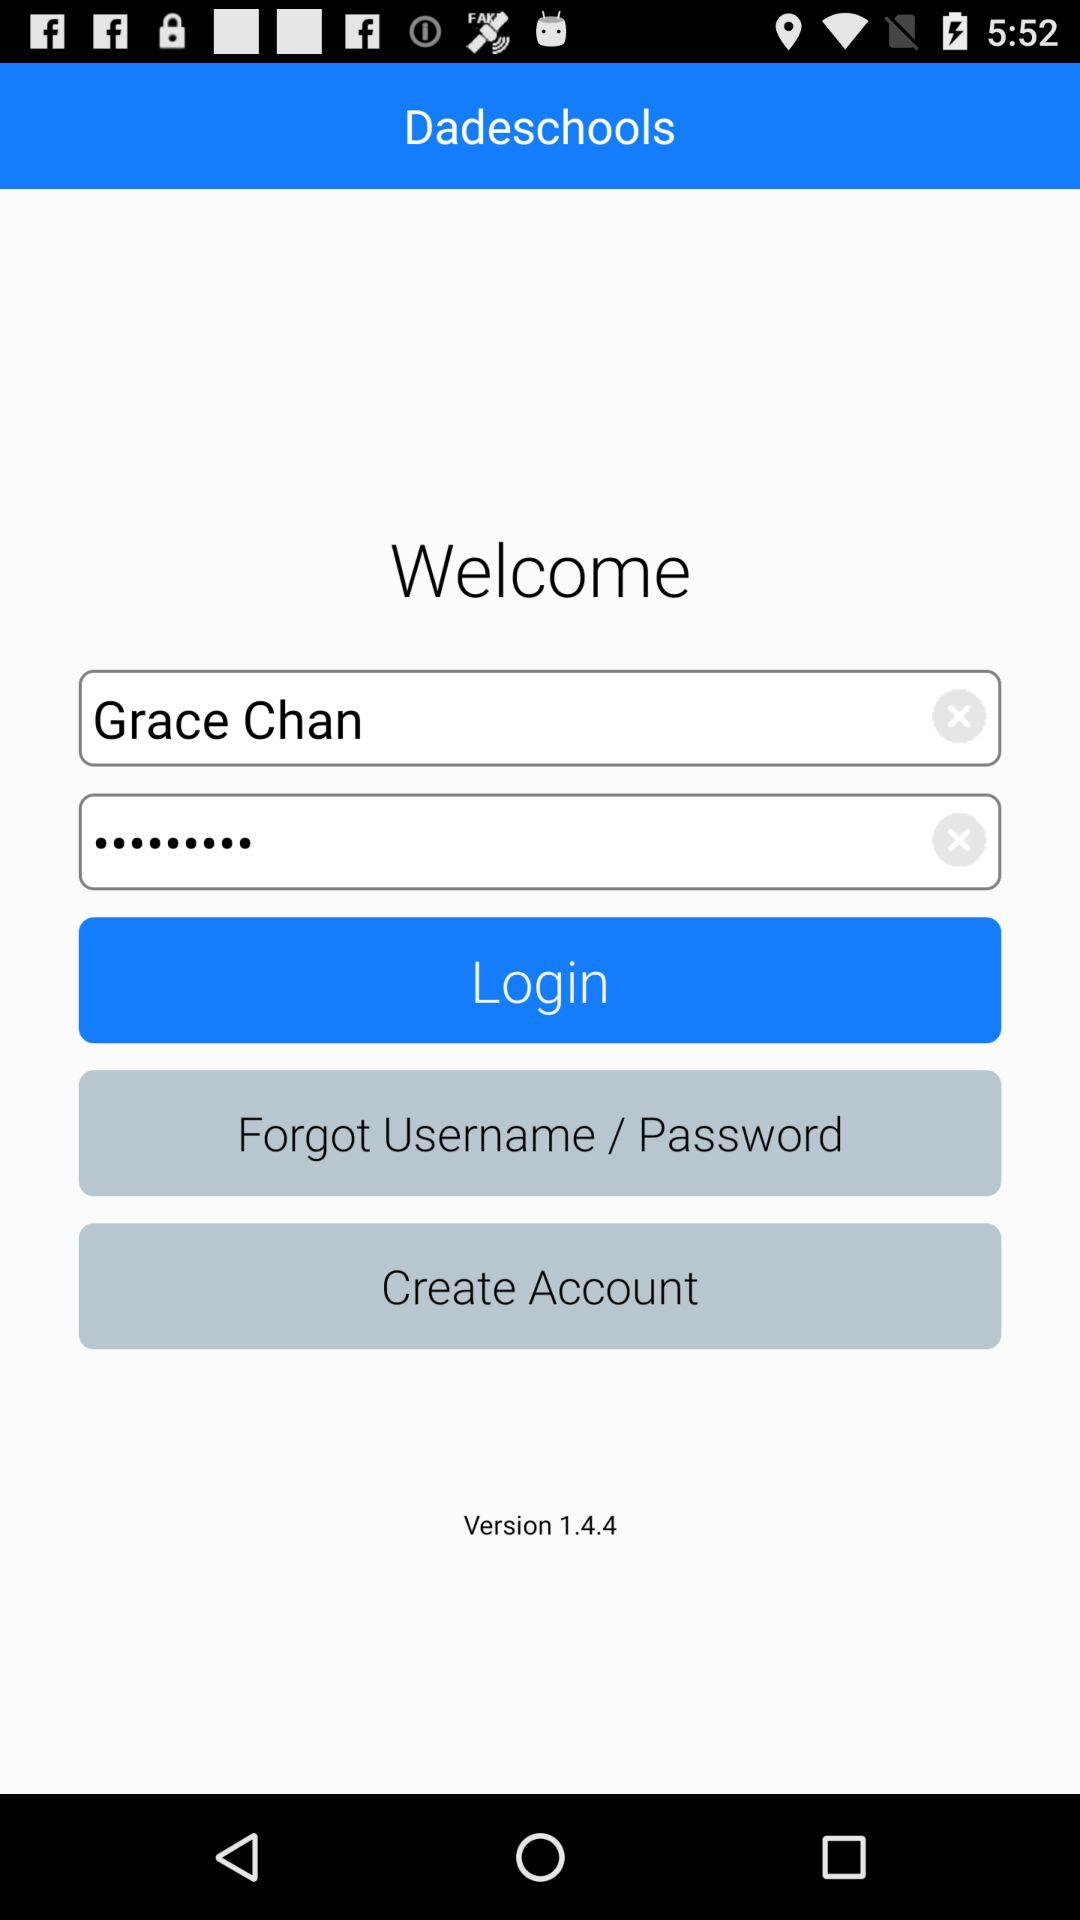What is the app name? The app name is "Dadeschools". 